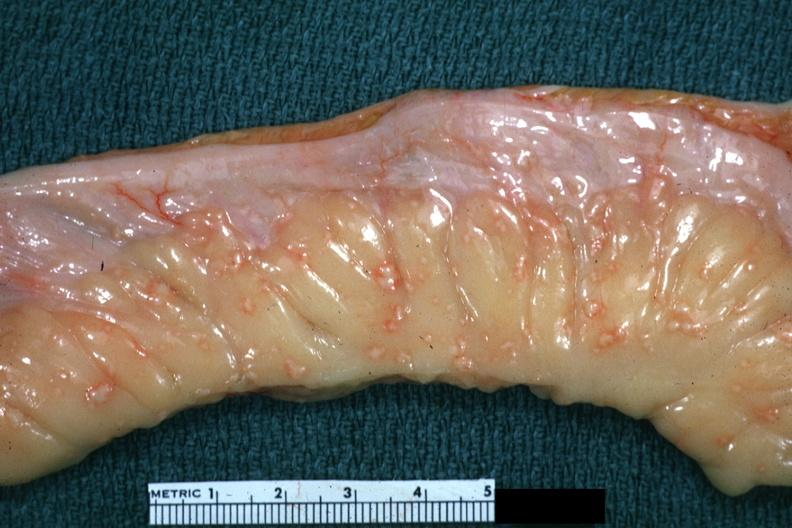what is present?
Answer the question using a single word or phrase. Abdomen 